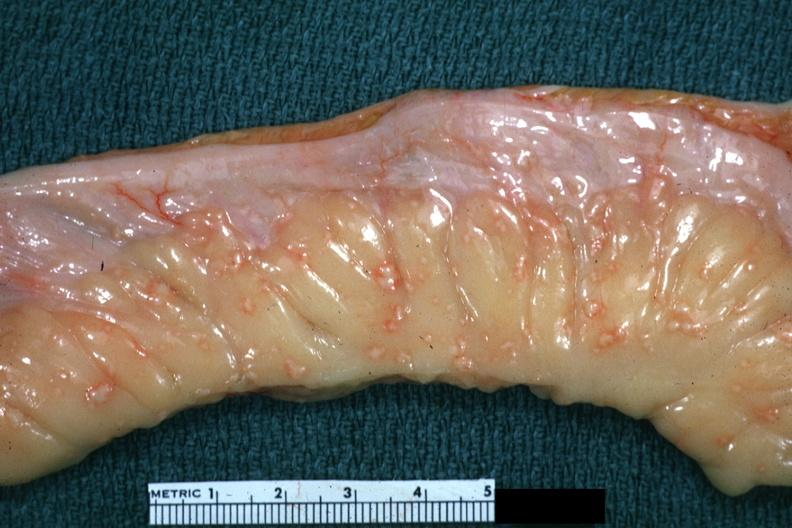what is present?
Answer the question using a single word or phrase. Abdomen 